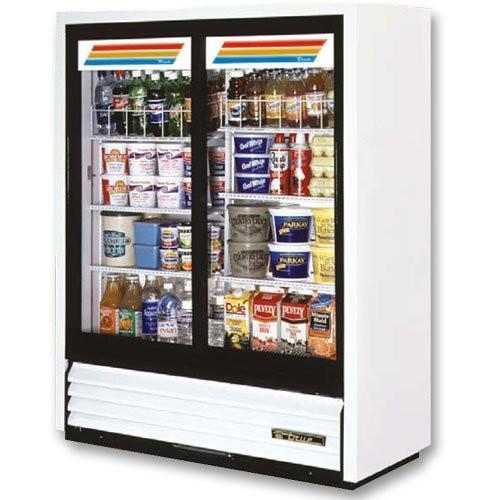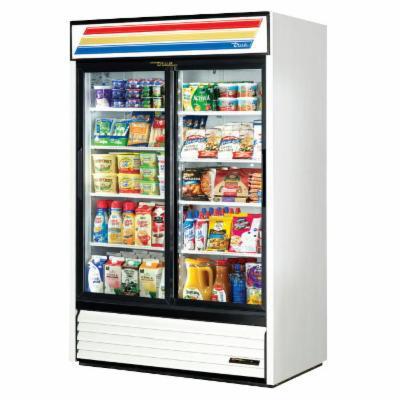The first image is the image on the left, the second image is the image on the right. Assess this claim about the two images: "At least two gallons of milk are on the bottom shelf.". Correct or not? Answer yes or no. No. The first image is the image on the left, the second image is the image on the right. Given the left and right images, does the statement "The cooler display in the right image has three colored lines across the top that run nearly the width of the machine." hold true? Answer yes or no. Yes. 